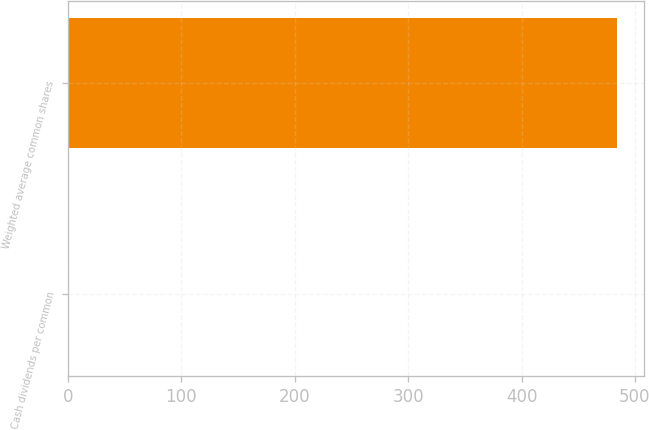<chart> <loc_0><loc_0><loc_500><loc_500><bar_chart><fcel>Cash dividends per common<fcel>Weighted average common shares<nl><fcel>0.64<fcel>484.04<nl></chart> 